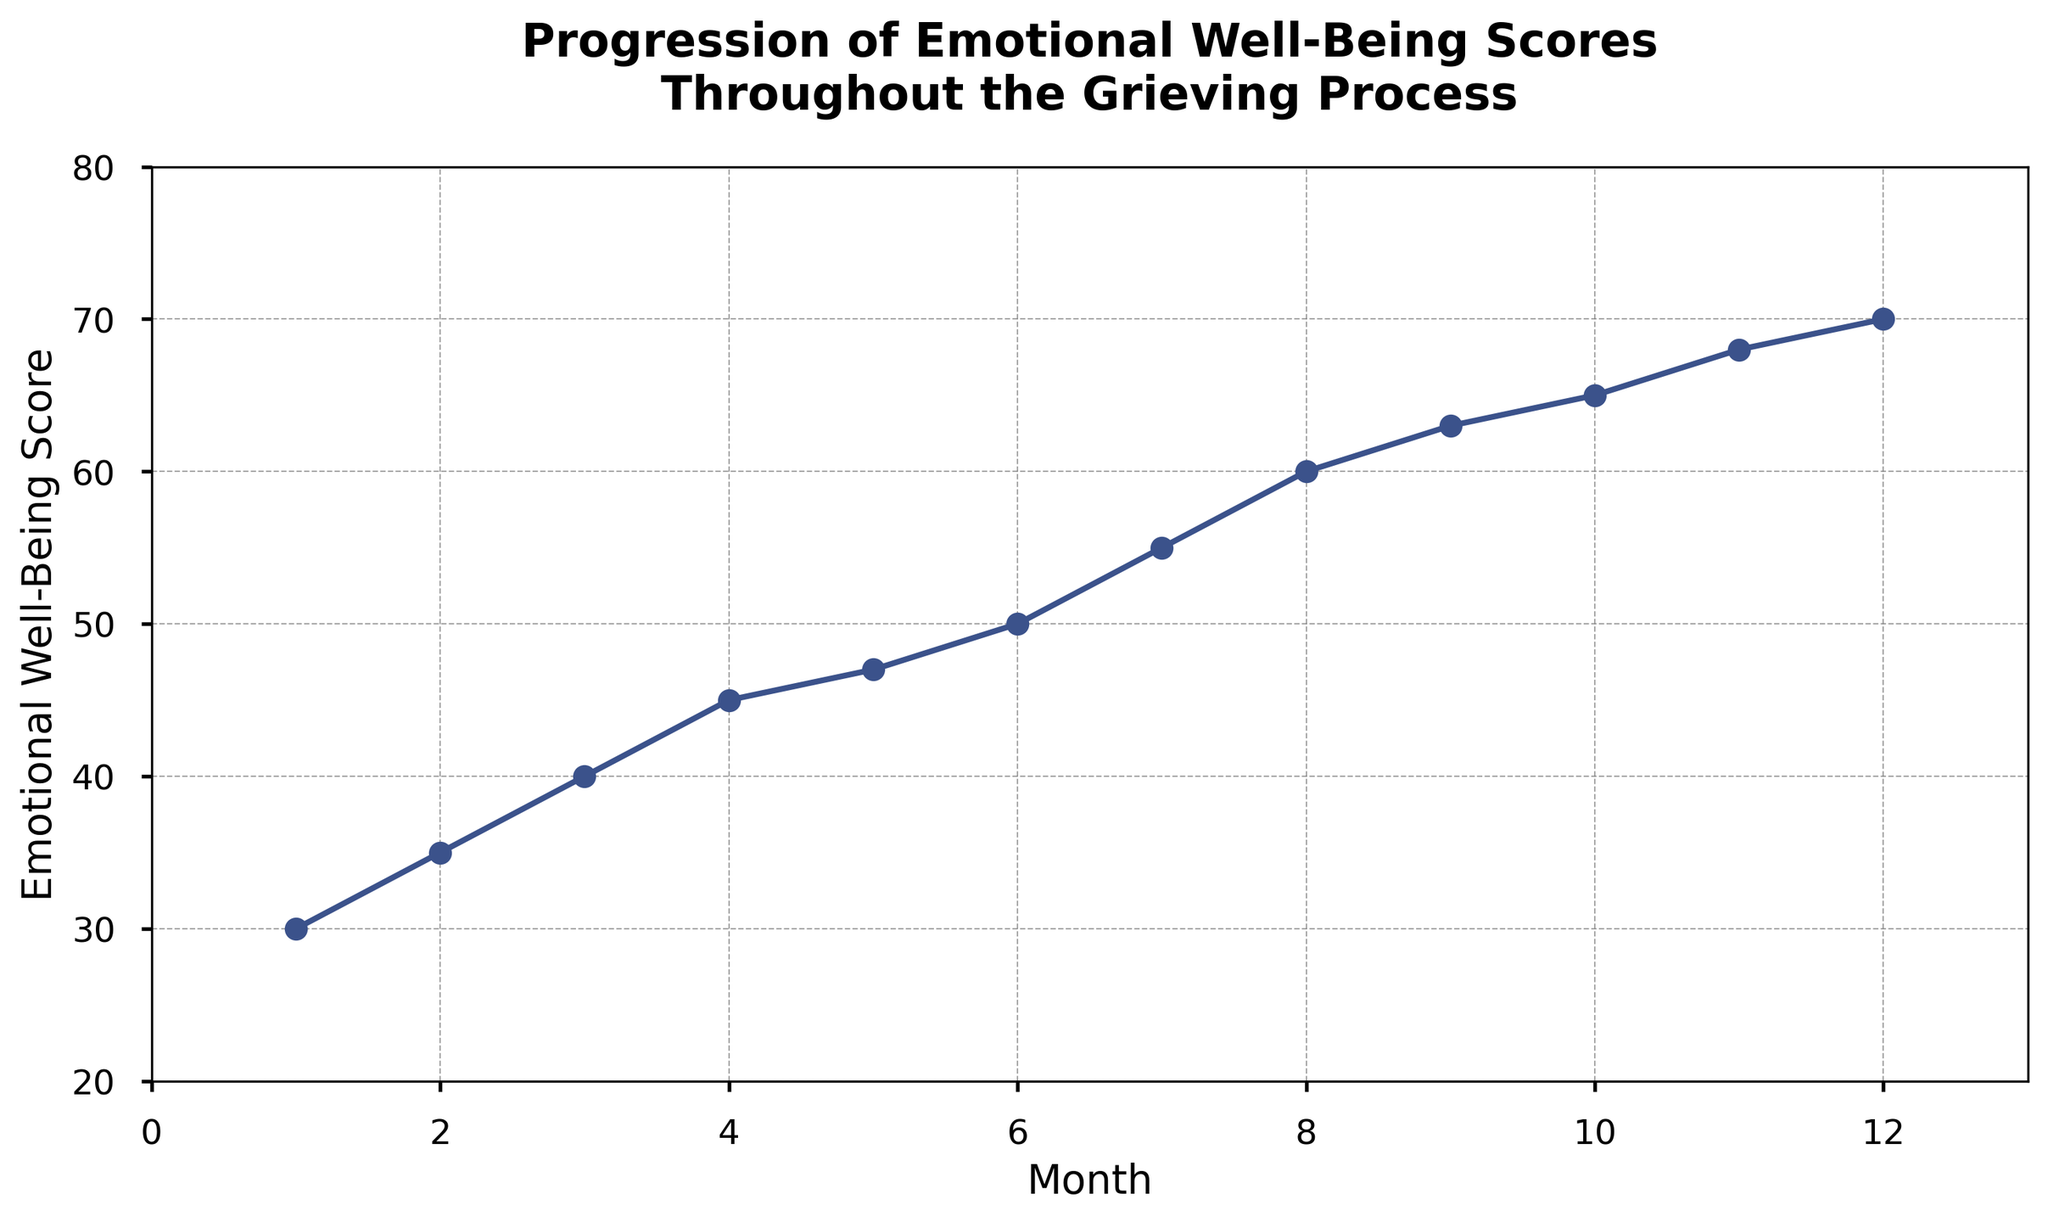What is the Emotional Well-Being Score in the 6th month? Check the data point for the 6th month on the x-axis, then find the corresponding y-axis value.
Answer: 50 How much did the Emotional Well-Being Score increase from the 1st month to the 12th month? Subtract the Emotional Well-Being Score of the 1st month from that of the 12th month (70 - 30).
Answer: 40 Between which two consecutive months does the largest increase in Emotional Well-Being Score occur? Compare the differences in scores between each consecutive month and identify the largest one (8th to 9th month: 63 - 60 = 3).
Answer: 8th to 9th month What is the average Emotional Well-Being Score over the 12 months? Sum all the Emotional Well-Being Scores and divide by the number of months (30+35+40+45+47+50+55+60+63+65+68+70) / 12.
Answer: 52.5 How does the trend of the Emotional Well-Being Score progress? Observe the general direction of the line plot (scores are steadily increasing each month).
Answer: Steadily increasing What is the difference in Emotional Well-Being Scores between the 4th and 10th months? Subtract the 4th month's score from the 10th month's score (65 - 45).
Answer: 20 Is there any month where the Emotional Well-Being Score plateaus or decreases? Examine the plot to see if there is any month where the score does not increase or decreases (No such month, all months show an increase).
Answer: No, it steadily increases Which month has an Emotional Well-Being Score closest to 50? Identify the month where the score is nearest to 50 (6th month).
Answer: 6th month Which month shows the smallest increase in Emotional Well-Being Score compared to the previous month? Calculate the month-to-month differences and find the smallest increase (from 4th to 5th month: 47 - 45 = 2).
Answer: 4th to 5th month Is the growth of Emotional Well-Being Score linear throughout the grieving process? Evaluate whether the increments between each month are constant (The increments vary slightly but the overall growth trend is linear).
Answer: No, it varies slightly but generally linear 